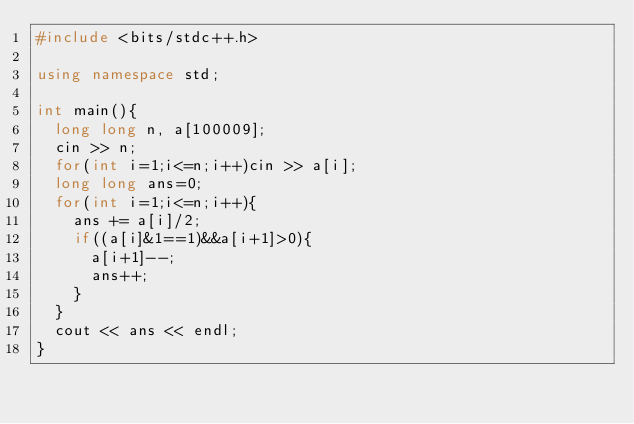Convert code to text. <code><loc_0><loc_0><loc_500><loc_500><_C++_>#include <bits/stdc++.h>

using namespace std;

int main(){
  long long n, a[100009];
  cin >> n;
  for(int i=1;i<=n;i++)cin >> a[i];
  long long ans=0;
  for(int i=1;i<=n;i++){
    ans += a[i]/2;
    if((a[i]&1==1)&&a[i+1]>0){
      a[i+1]--;
      ans++;
    }
  }
  cout << ans << endl;
}

</code> 